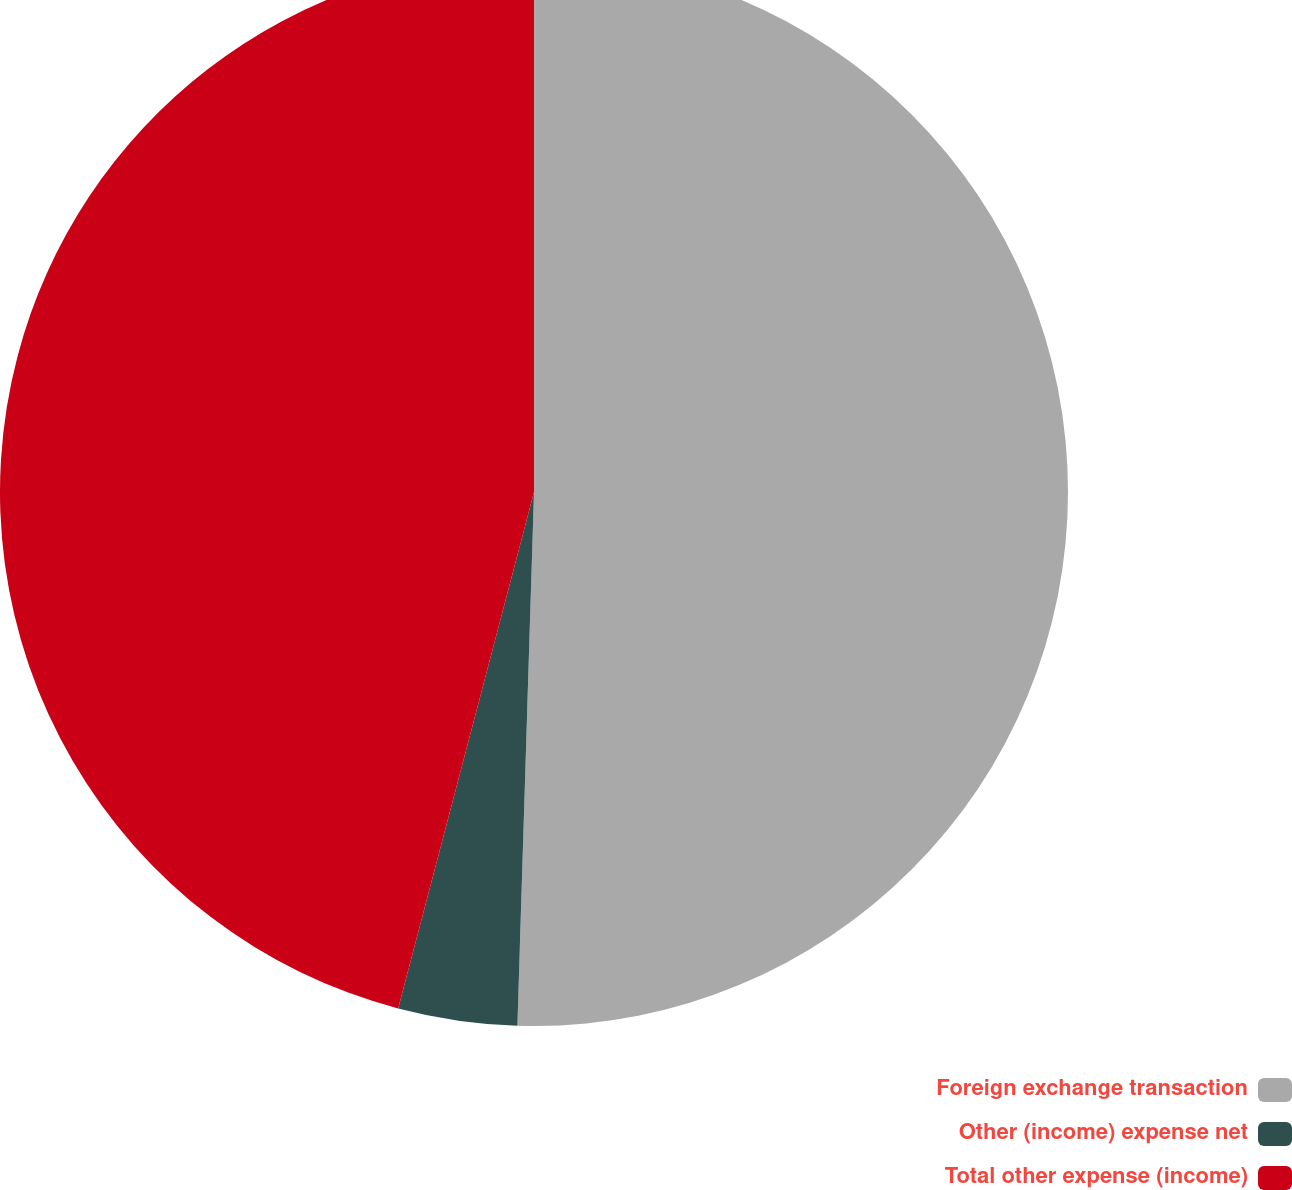Convert chart. <chart><loc_0><loc_0><loc_500><loc_500><pie_chart><fcel>Foreign exchange transaction<fcel>Other (income) expense net<fcel>Total other expense (income)<nl><fcel>50.5%<fcel>3.6%<fcel>45.91%<nl></chart> 